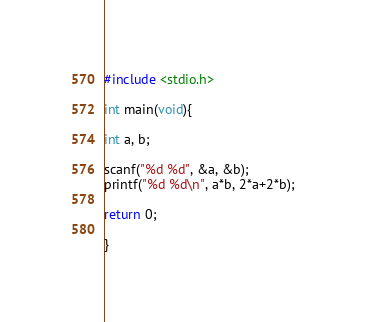Convert code to text. <code><loc_0><loc_0><loc_500><loc_500><_C_>#include <stdio.h>

int main(void){

int a, b;

scanf("%d %d", &a, &b);
printf("%d %d\n", a*b, 2*a+2*b);

return 0;

}</code> 